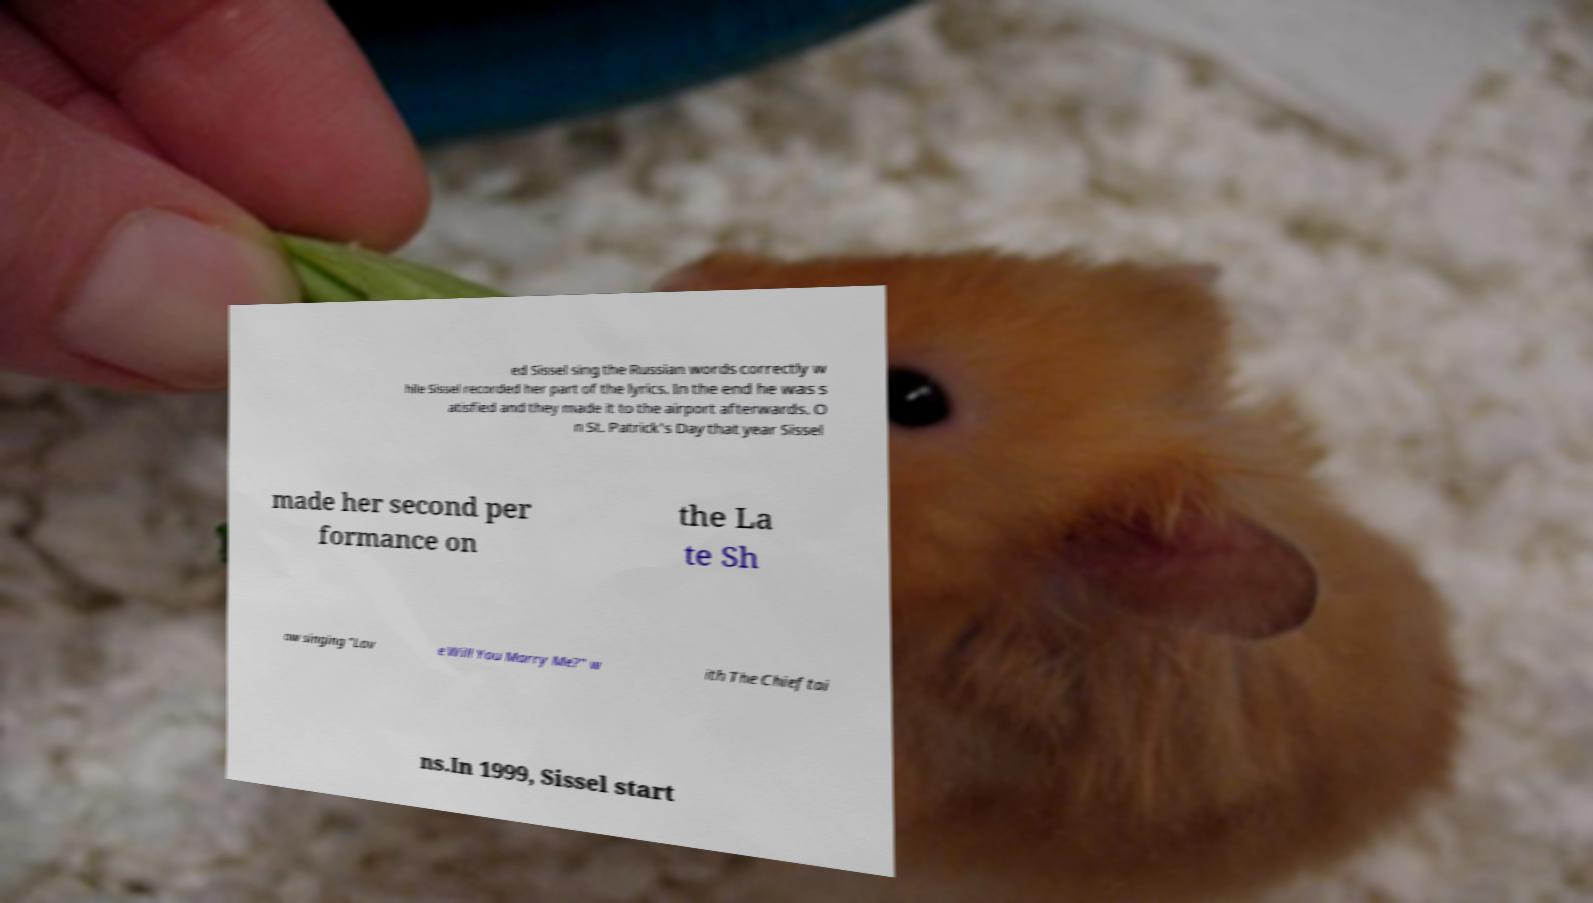Could you assist in decoding the text presented in this image and type it out clearly? ed Sissel sing the Russian words correctly w hile Sissel recorded her part of the lyrics. In the end he was s atisfied and they made it to the airport afterwards. O n St. Patrick's Day that year Sissel made her second per formance on the La te Sh ow singing "Lov e Will You Marry Me?" w ith The Chieftai ns.In 1999, Sissel start 